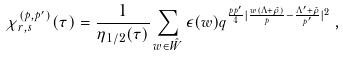Convert formula to latex. <formula><loc_0><loc_0><loc_500><loc_500>\chi ^ { ( p , p ^ { \prime } ) } _ { r , s } ( \tau ) = \frac { 1 } { \eta _ { 1 / 2 } ( \tau ) } \sum _ { w \in \hat { W } } \epsilon ( w ) { q ^ { \frac { p p ^ { \prime } } { 4 } | \frac { w ( \Lambda + \hat { \rho } ) } { p } - \frac { \Lambda ^ { \prime } + \hat { \rho } } { p ^ { \prime } } | ^ { 2 } } } \, ,</formula> 